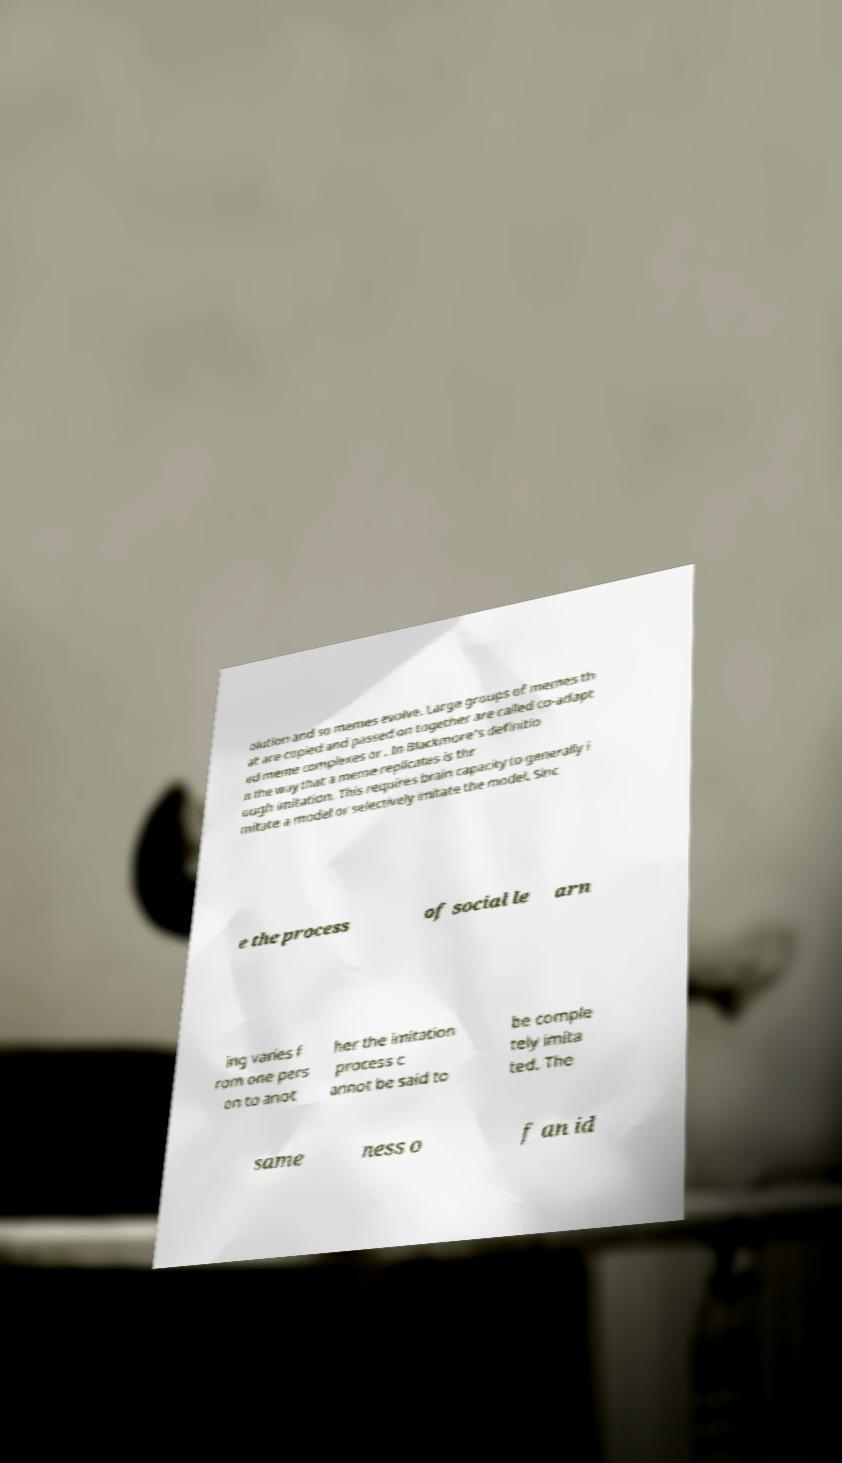What messages or text are displayed in this image? I need them in a readable, typed format. olution and so memes evolve. Large groups of memes th at are copied and passed on together are called co-adapt ed meme complexes or . In Blackmore's definitio n the way that a meme replicates is thr ough imitation. This requires brain capacity to generally i mitate a model or selectively imitate the model. Sinc e the process of social le arn ing varies f rom one pers on to anot her the imitation process c annot be said to be comple tely imita ted. The same ness o f an id 